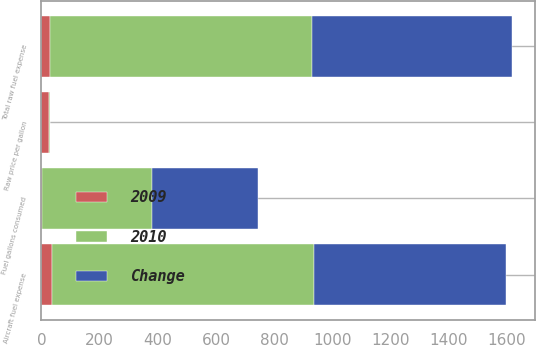Convert chart to OTSL. <chart><loc_0><loc_0><loc_500><loc_500><stacked_bar_chart><ecel><fcel>Fuel gallons consumed<fcel>Raw price per gallon<fcel>Total raw fuel expense<fcel>Aircraft fuel expense<nl><fcel>2010<fcel>377.3<fcel>2.38<fcel>898.9<fcel>900.9<nl><fcel>Change<fcel>365<fcel>1.88<fcel>686.2<fcel>658.1<nl><fcel>2009<fcel>3.4<fcel>26.6<fcel>31<fcel>36.9<nl></chart> 